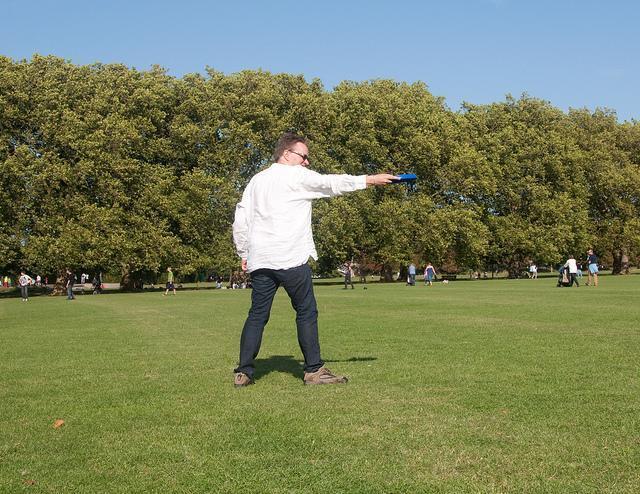How many umbrellas are there?
Give a very brief answer. 0. 